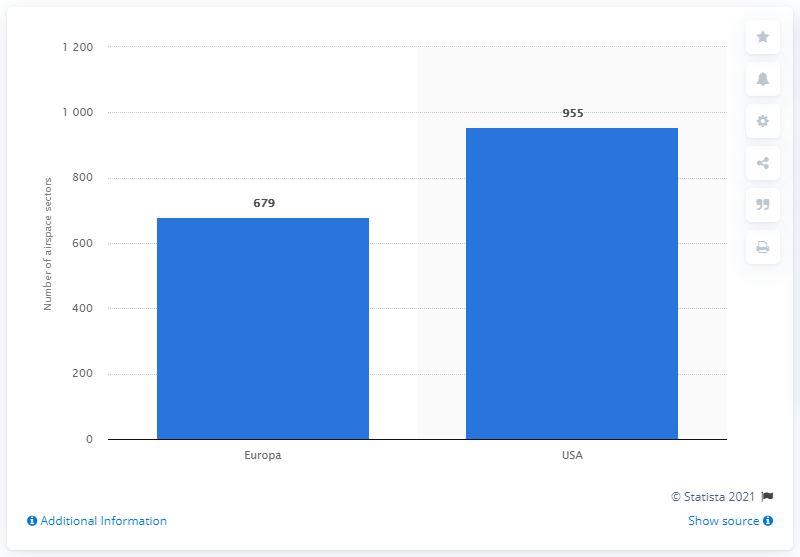Give some essential details in this illustration. In 2008, there were 955 airspace sectors in the United States. 